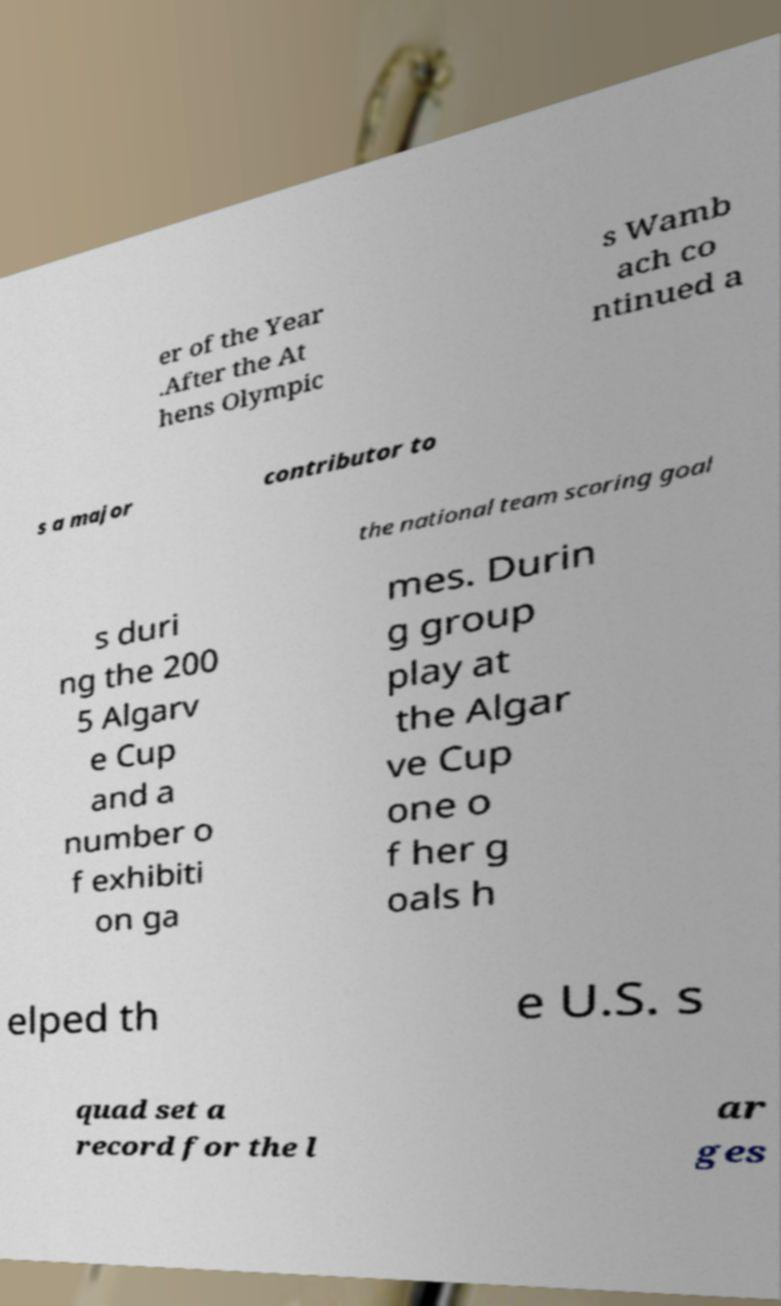Could you extract and type out the text from this image? er of the Year .After the At hens Olympic s Wamb ach co ntinued a s a major contributor to the national team scoring goal s duri ng the 200 5 Algarv e Cup and a number o f exhibiti on ga mes. Durin g group play at the Algar ve Cup one o f her g oals h elped th e U.S. s quad set a record for the l ar ges 